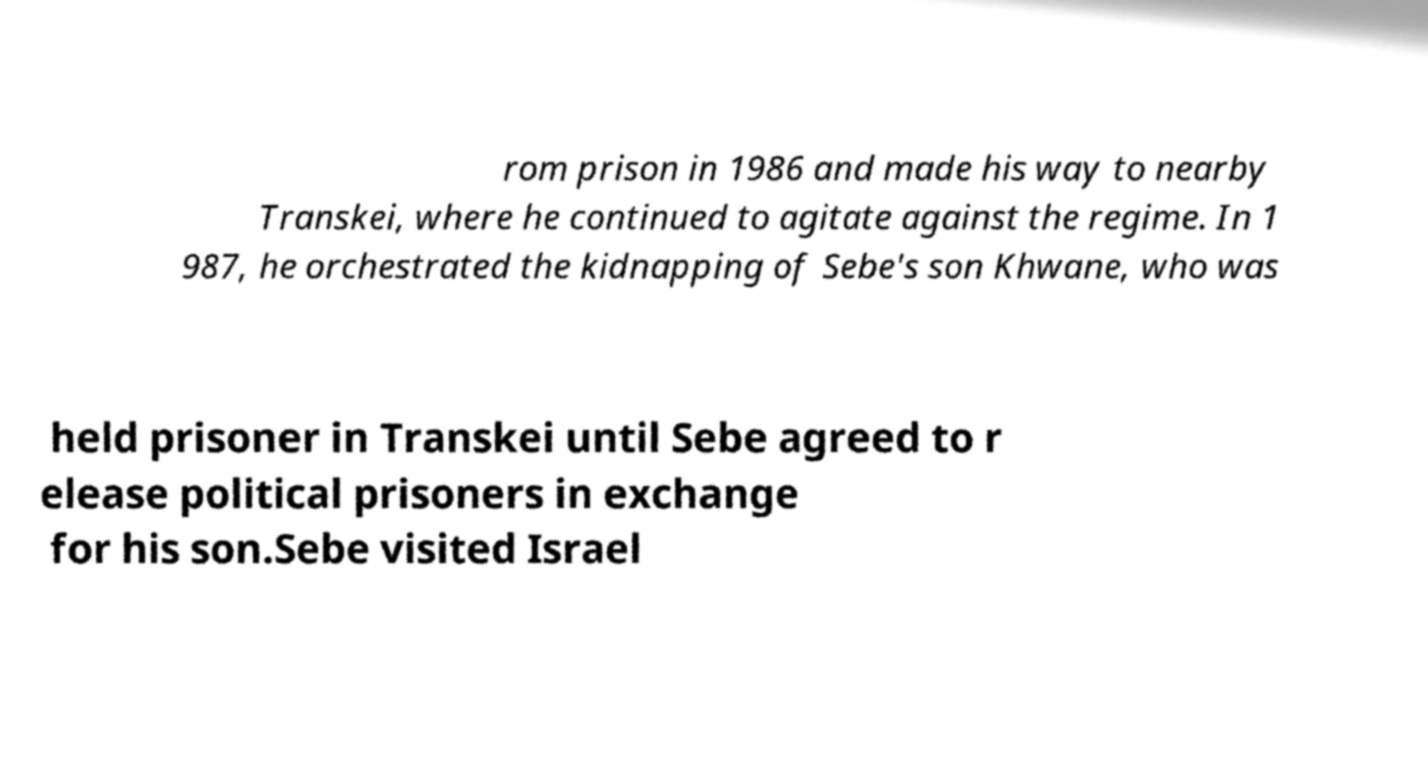Can you read and provide the text displayed in the image?This photo seems to have some interesting text. Can you extract and type it out for me? rom prison in 1986 and made his way to nearby Transkei, where he continued to agitate against the regime. In 1 987, he orchestrated the kidnapping of Sebe's son Khwane, who was held prisoner in Transkei until Sebe agreed to r elease political prisoners in exchange for his son.Sebe visited Israel 